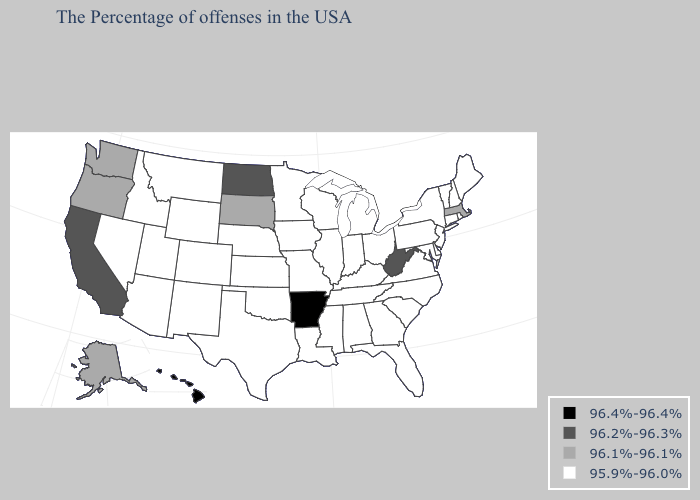What is the value of New York?
Answer briefly. 95.9%-96.0%. What is the highest value in the South ?
Give a very brief answer. 96.4%-96.4%. Name the states that have a value in the range 96.2%-96.3%?
Short answer required. West Virginia, North Dakota, California. Which states hav the highest value in the South?
Write a very short answer. Arkansas. Does Delaware have the lowest value in the South?
Concise answer only. Yes. What is the value of West Virginia?
Keep it brief. 96.2%-96.3%. Does California have the same value as North Dakota?
Answer briefly. Yes. What is the highest value in the MidWest ?
Keep it brief. 96.2%-96.3%. Among the states that border New Jersey , which have the lowest value?
Concise answer only. New York, Delaware, Pennsylvania. What is the highest value in states that border Oregon?
Short answer required. 96.2%-96.3%. What is the value of Indiana?
Quick response, please. 95.9%-96.0%. What is the lowest value in the West?
Write a very short answer. 95.9%-96.0%. Is the legend a continuous bar?
Concise answer only. No. What is the value of New Hampshire?
Write a very short answer. 95.9%-96.0%. Which states hav the highest value in the South?
Write a very short answer. Arkansas. 